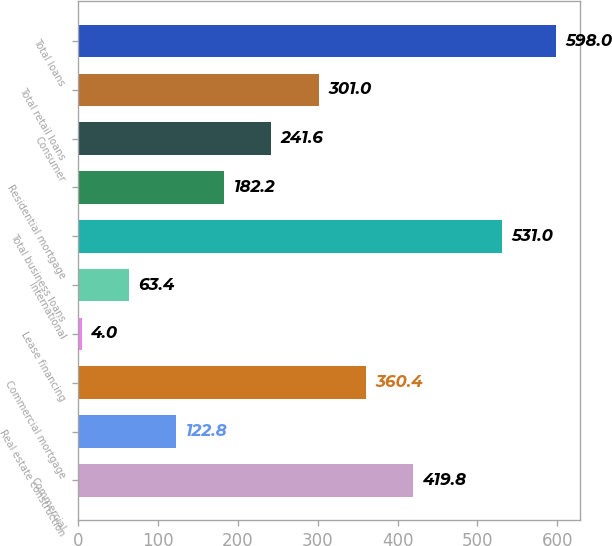Convert chart. <chart><loc_0><loc_0><loc_500><loc_500><bar_chart><fcel>Commercial<fcel>Real estate construction<fcel>Commercial mortgage<fcel>Lease financing<fcel>International<fcel>Total business loans<fcel>Residential mortgage<fcel>Consumer<fcel>Total retail loans<fcel>Total loans<nl><fcel>419.8<fcel>122.8<fcel>360.4<fcel>4<fcel>63.4<fcel>531<fcel>182.2<fcel>241.6<fcel>301<fcel>598<nl></chart> 